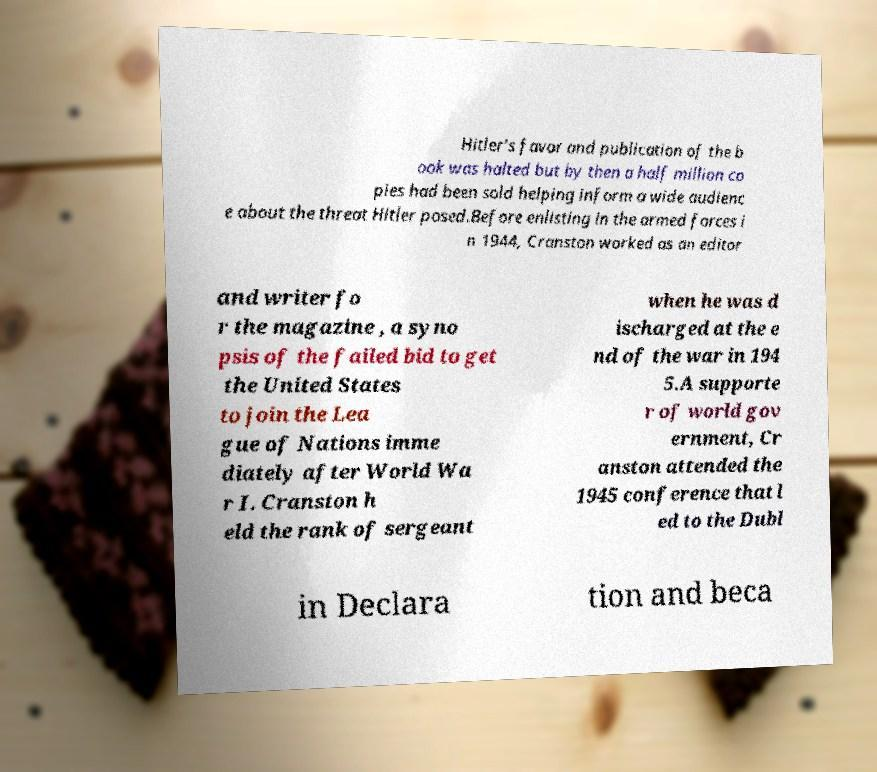For documentation purposes, I need the text within this image transcribed. Could you provide that? Hitler's favor and publication of the b ook was halted but by then a half million co pies had been sold helping inform a wide audienc e about the threat Hitler posed.Before enlisting in the armed forces i n 1944, Cranston worked as an editor and writer fo r the magazine , a syno psis of the failed bid to get the United States to join the Lea gue of Nations imme diately after World Wa r I. Cranston h eld the rank of sergeant when he was d ischarged at the e nd of the war in 194 5.A supporte r of world gov ernment, Cr anston attended the 1945 conference that l ed to the Dubl in Declara tion and beca 